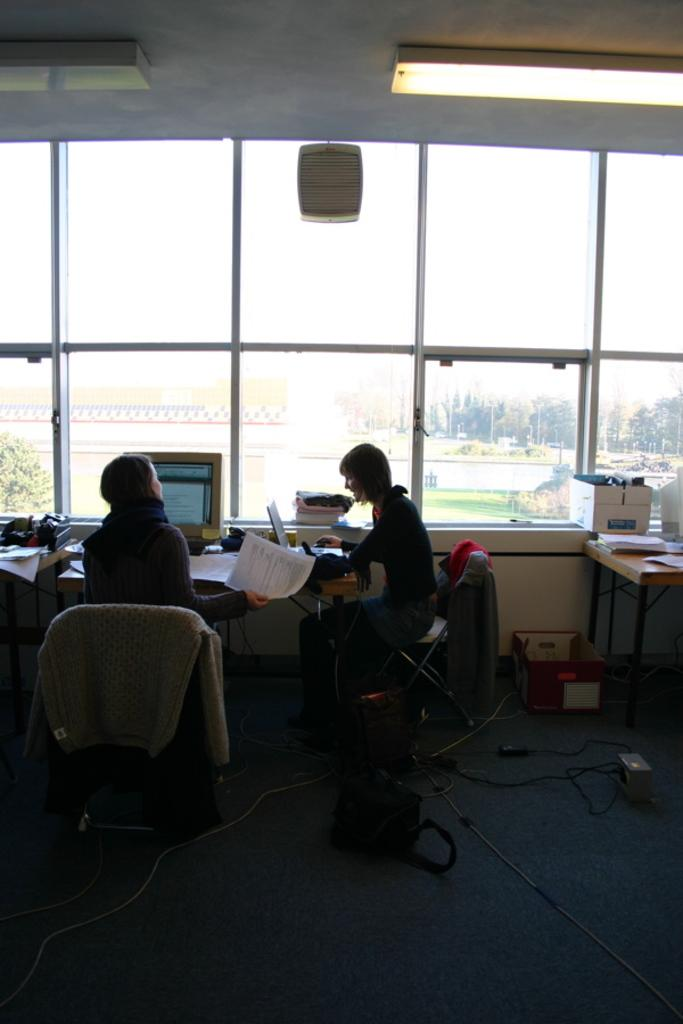What are the people in the image doing? The people in the image are sitting on chairs near a table. What is the main piece of furniture in the image? There is a table in the image. What can be seen through the glass windows in the background? Trees and a building are visible through the glass windows. How many tomatoes are on the table in the image? There is no mention of tomatoes in the image, so we cannot determine their presence or quantity. What type of zebra can be seen walking near the building in the image? There is no zebra present in the image, so we cannot describe its appearance or actions. 